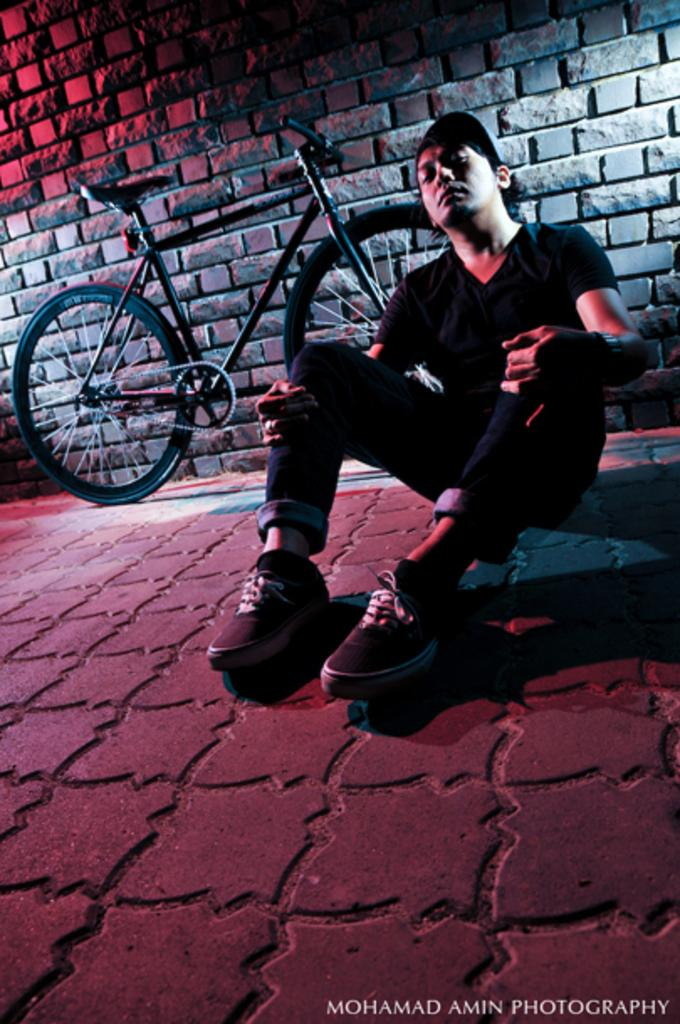What is the man doing in the image? The man is sitting on the floor on the right side of the image. What is the man wearing in the image? The man is wearing a shirt, trousers, and shoes in the image. What can be seen on the left side of the image? There is a cycle on the left side of the image. How many rings can be seen on the man's fingers in the image? There is no information about rings on the man's fingers in the image. Is there a tent visible in the image? There is no tent present in the image. 